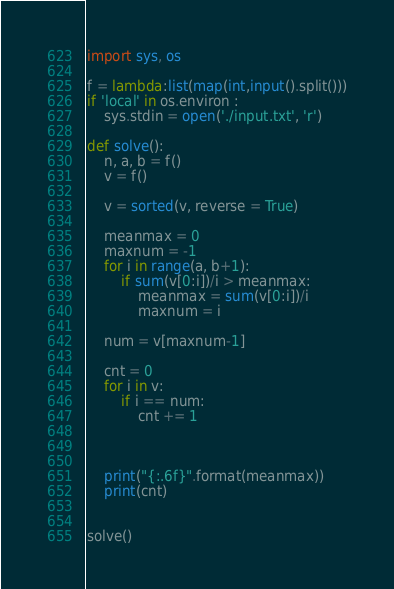<code> <loc_0><loc_0><loc_500><loc_500><_Python_>import sys, os

f = lambda:list(map(int,input().split()))
if 'local' in os.environ :
    sys.stdin = open('./input.txt', 'r')

def solve():
    n, a, b = f()
    v = f()
    
    v = sorted(v, reverse = True)

    meanmax = 0 
    maxnum = -1
    for i in range(a, b+1):
        if sum(v[0:i])/i > meanmax:
            meanmax = sum(v[0:i])/i
            maxnum = i
    
    num = v[maxnum-1]

    cnt = 0
    for i in v:
        if i == num:
            cnt += 1



    print("{:.6f}".format(meanmax))
    print(cnt)


solve()
</code> 